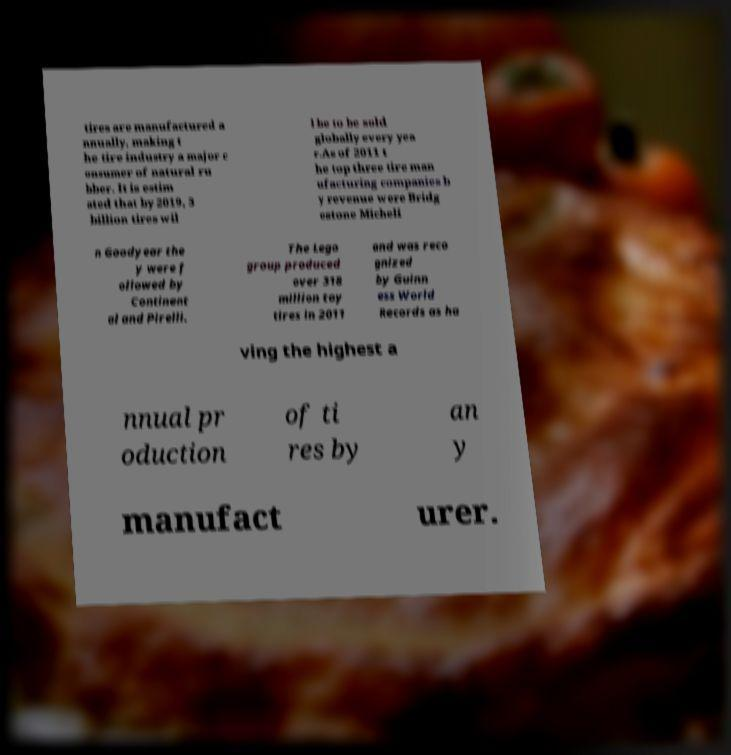Can you read and provide the text displayed in the image?This photo seems to have some interesting text. Can you extract and type it out for me? tires are manufactured a nnually, making t he tire industry a major c onsumer of natural ru bber. It is estim ated that by 2019, 3 billion tires wil l be to be sold globally every yea r.As of 2011 t he top three tire man ufacturing companies b y revenue were Bridg estone Micheli n Goodyear the y were f ollowed by Continent al and Pirelli. The Lego group produced over 318 million toy tires in 2011 and was reco gnized by Guinn ess World Records as ha ving the highest a nnual pr oduction of ti res by an y manufact urer. 